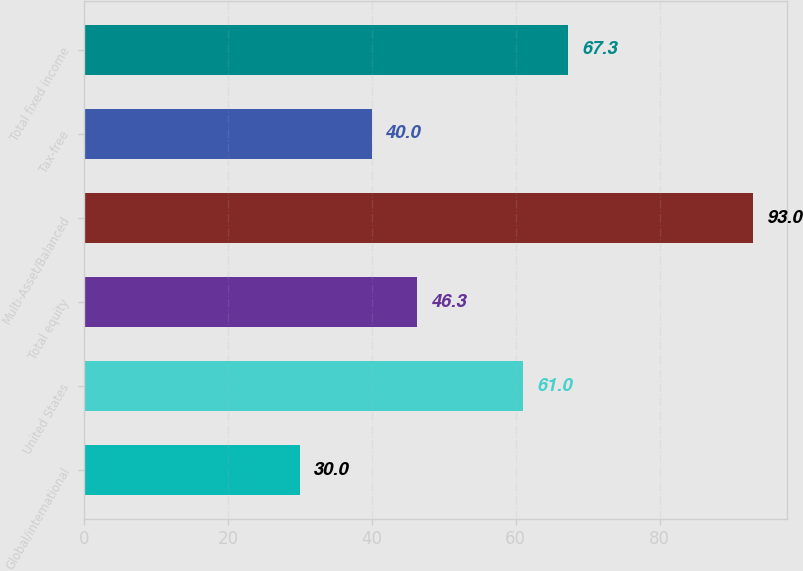Convert chart. <chart><loc_0><loc_0><loc_500><loc_500><bar_chart><fcel>Global/international<fcel>United States<fcel>Total equity<fcel>Multi-Asset/Balanced<fcel>Tax-free<fcel>Total fixed income<nl><fcel>30<fcel>61<fcel>46.3<fcel>93<fcel>40<fcel>67.3<nl></chart> 